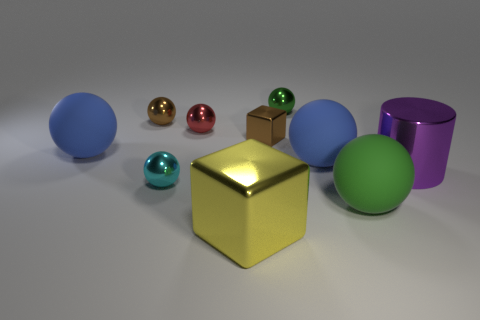Can you tell me the colors of the spheres and their sizes in relation to each other? Certainly, there are five spheres varying in colors and sizes. Starting with the largest, we have a blue one, then a slightly smaller green one, followed by a small red, a small gold, and an even smaller turquoise one. The blue sphere is the largest and the turquoise is the smallest. 